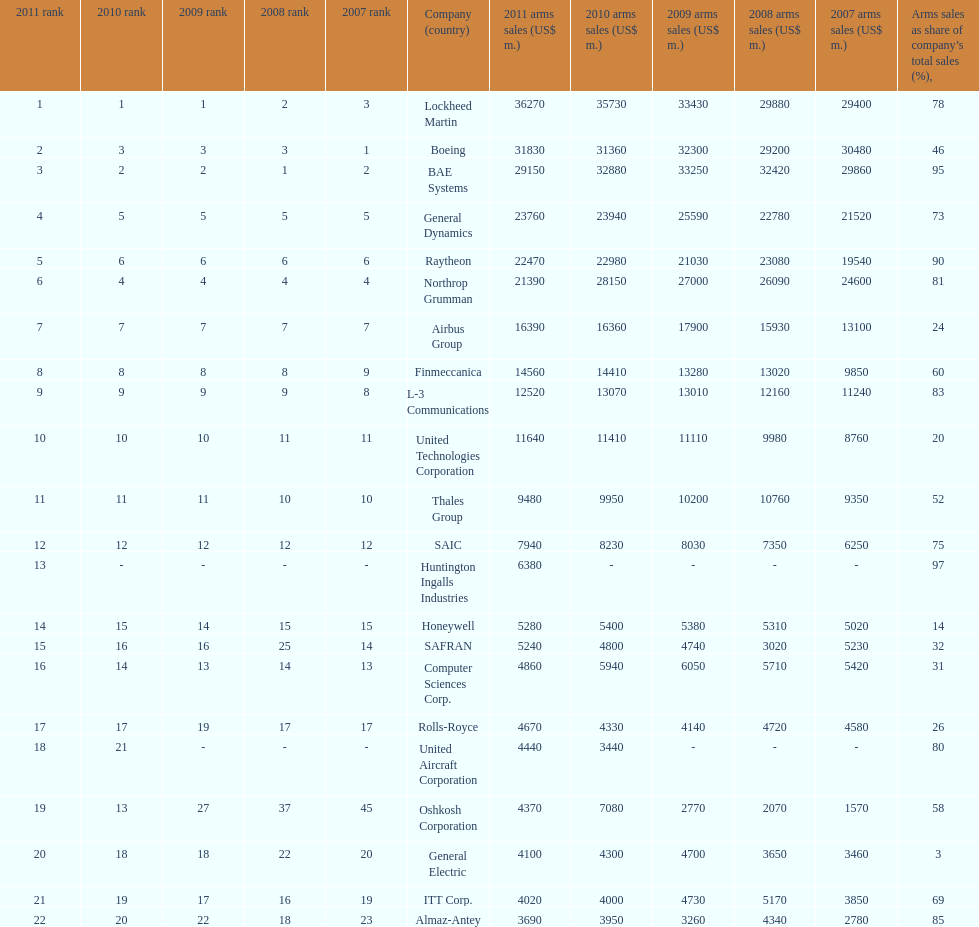Identify all the firms where the proportion of weapons sales to their total revenue falls below 75%. Boeing, General Dynamics, Airbus Group, Finmeccanica, United Technologies Corporation, Thales Group, Honeywell, SAFRAN, Computer Sciences Corp., Rolls-Royce, Oshkosh Corporation, General Electric, ITT Corp. 